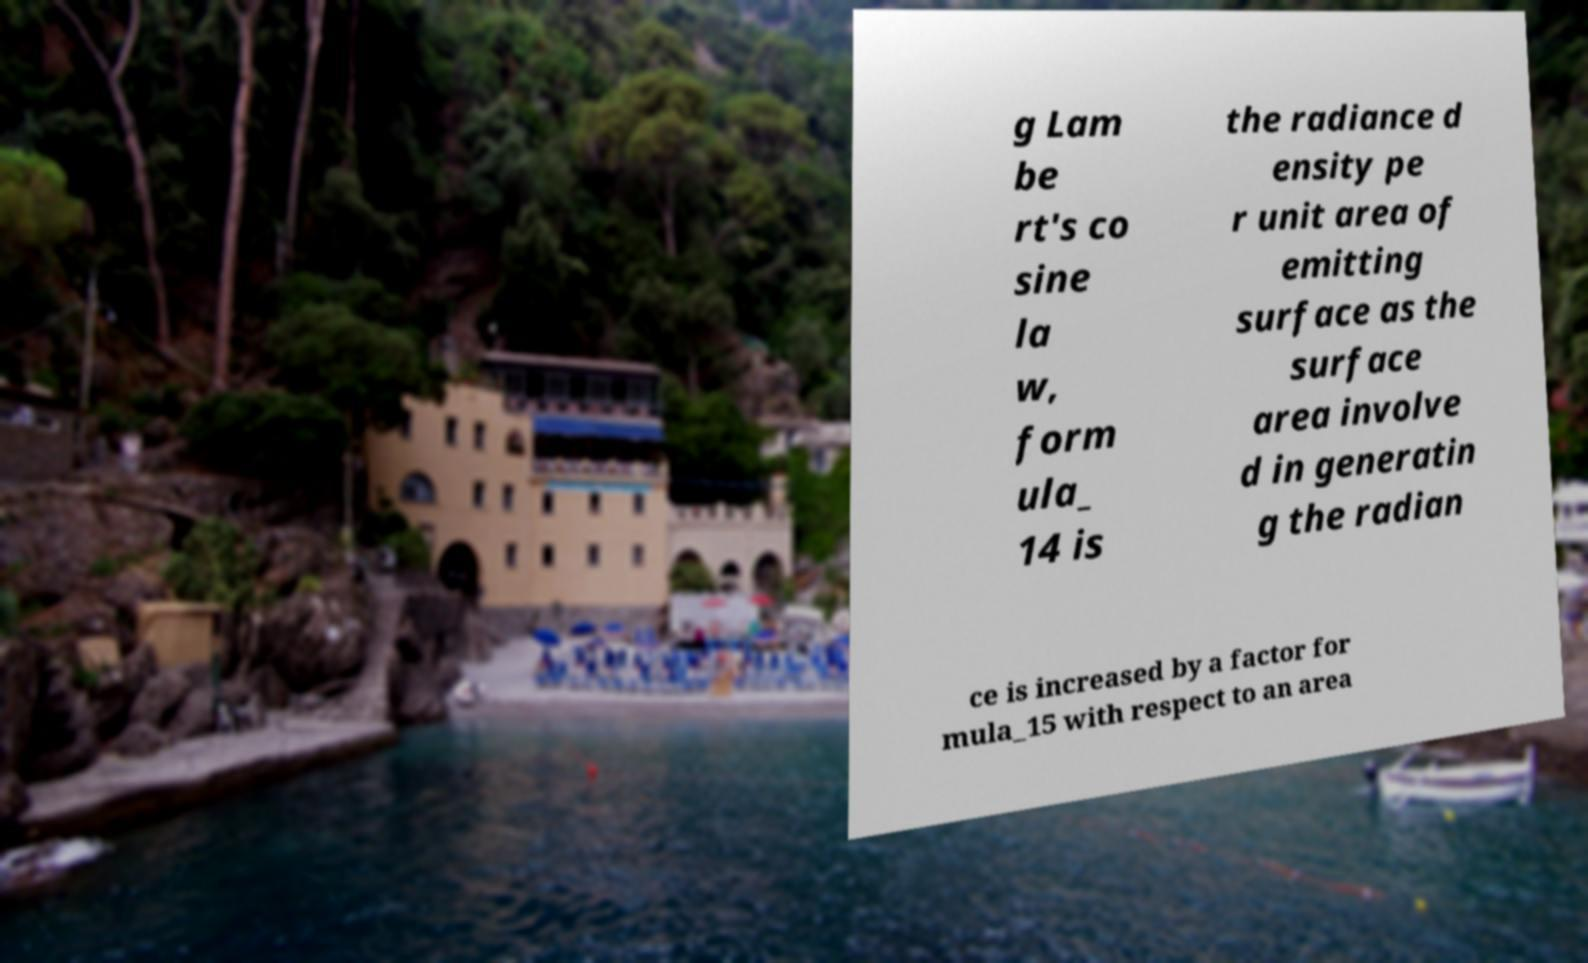What messages or text are displayed in this image? I need them in a readable, typed format. g Lam be rt's co sine la w, form ula_ 14 is the radiance d ensity pe r unit area of emitting surface as the surface area involve d in generatin g the radian ce is increased by a factor for mula_15 with respect to an area 